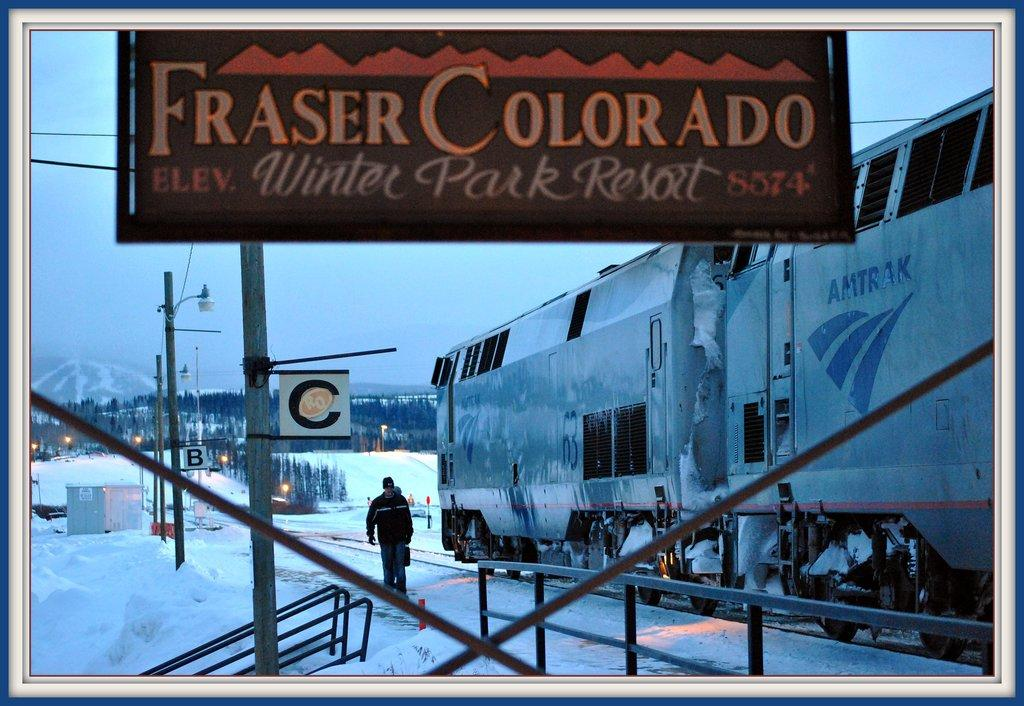Provide a one-sentence caption for the provided image. An outdoor billboard titled Fraser Colorado on it. 